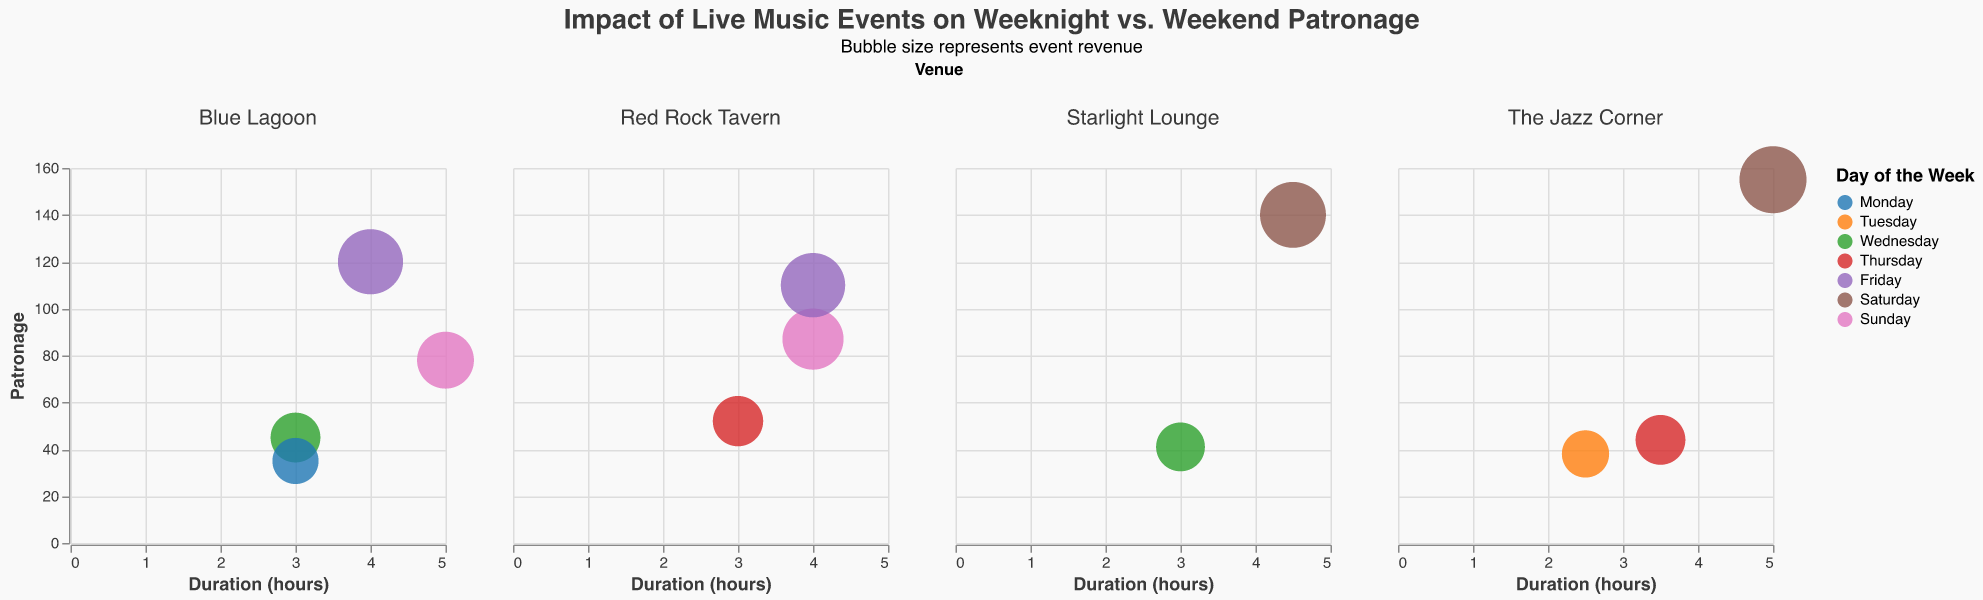what is the title of the figure? The title of the figure is located at the top, center-aligned, and is a textual element that describes the main focus of the visual. The title reads "Impact of Live Music Events on Weeknight vs. Weekend Patronage."
Answer: Impact of Live Music Events on Weeknight vs. Weekend Patronage Which day had the highest event revenue at Red Rock Tavern? By looking at the color of the bubbles for Red Rock Tavern, we identify the day and revenue from the tooltip. The largest bubble observed on Friday has the highest revenue of $3,300.
Answer: Friday What's the average patronage of Blue Lagoon events? Locate the bubbles in the Blue Lagoon subplot and read the patronage values from the tooltips. Sum these values (45+120+35+78) and divide by the number of events (4) to find the average.
Answer: 69.5 Compare the patronage of Wednesday events at Blue Lagoon and Starlight Lounge. Which venue had more patronage? Check the two Wednesday bubbles in Blue Lagoon and Starlight Lounge. Blue Lagoon has 45 patrons, while Starlight Lounge has 41 patrons. Blue Lagoon has a higher patronage than Starlight Lounge on Wednesday.
Answer: Blue Lagoon What is the relationship between event duration and patronage for Saturday events at Starlight Lounge and The Jazz Corner? Identify the Saturday bubbles in both venues' subplots and observe the duration and patronage values. For Starlight Lounge, duration is 4.5 hours with 140 patrons. For The Jazz Corner, duration is 5 hours with 155 patrons. Both have high patronage with longer durations.
Answer: Longer durations, higher patronage Does Red Rock Tavern have higher average revenue on weekdays or weekends? Weekdays for Red Rock Tavern are Thursday and Friday; weekends are Sunday. Add Thursday and Friday revenue ($1,560 + $3,300 = $4,860), average is $2,430. Sunday revenue is $2,610. Compare $2,430 (weekdays) with $2,610 (weekends).
Answer: Weekends Which venue has the bubble with the smallest size, and what is the revenue for that event? Observe the subplots and find the smallest bubble, which is at Blue Lagoon on Monday with a bubble size of 380, corresponding to a revenue of $1,050.
Answer: Blue Lagoon, $1,050 Which venue has the most consistent patronage across all events? Examine each venue's subplot for the range of patronage values. Starlight Lounge has values 41 and 140; Red Rock Tavern has a range of 52 to 110; Blue Lagoon has 35 to 120; The Jazz Corner has the smallest range of 38 to 155.
Answer: Starlight Lounge Summarize the patronage and event duration for Wednesday events across all venues. Identify Wednesday bubbles in subplots. Blue Lagoon: 45 patrons, 3 hours; Starlight Lounge: 41 patrons, 3 hours. Summarize these events' patronage and durations.
Answer: Blue Lagoon: 45 patrons, 3 hours; Starlight Lounge: 41 patrons, 3 hours 